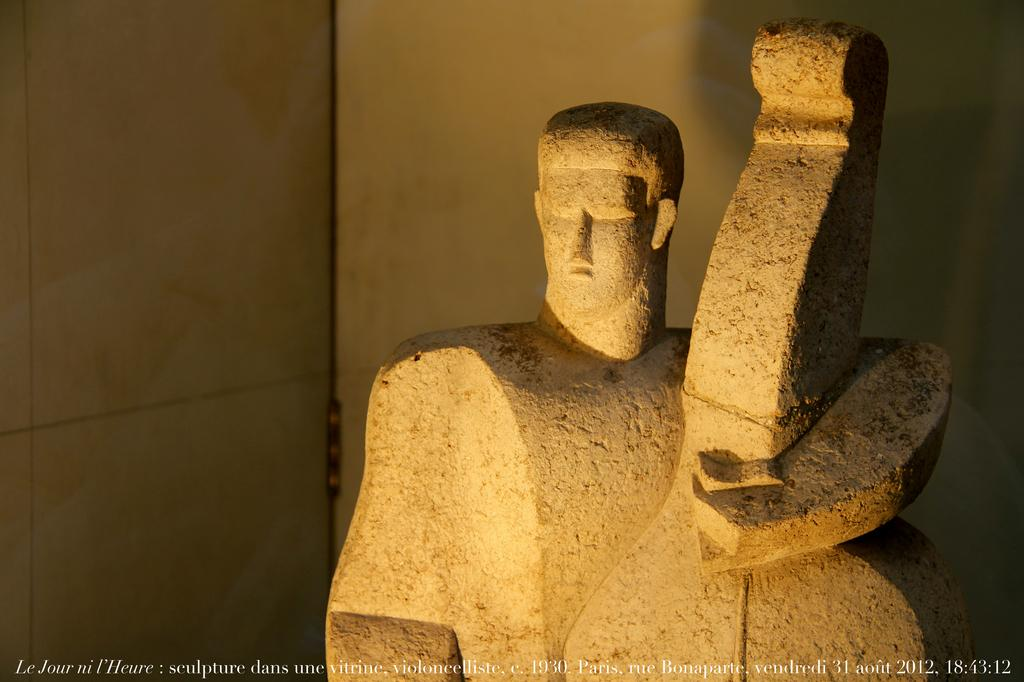What is the main subject in the image? There is a statue in the image. What else can be seen in the image besides the statue? There are walls visible in the image. Is there any text present in the image? Yes, there is text visible at the bottom of the image. How does the statue use its elbow in the image? The statue does not have an elbow, as it is an inanimate object and not a living being. 